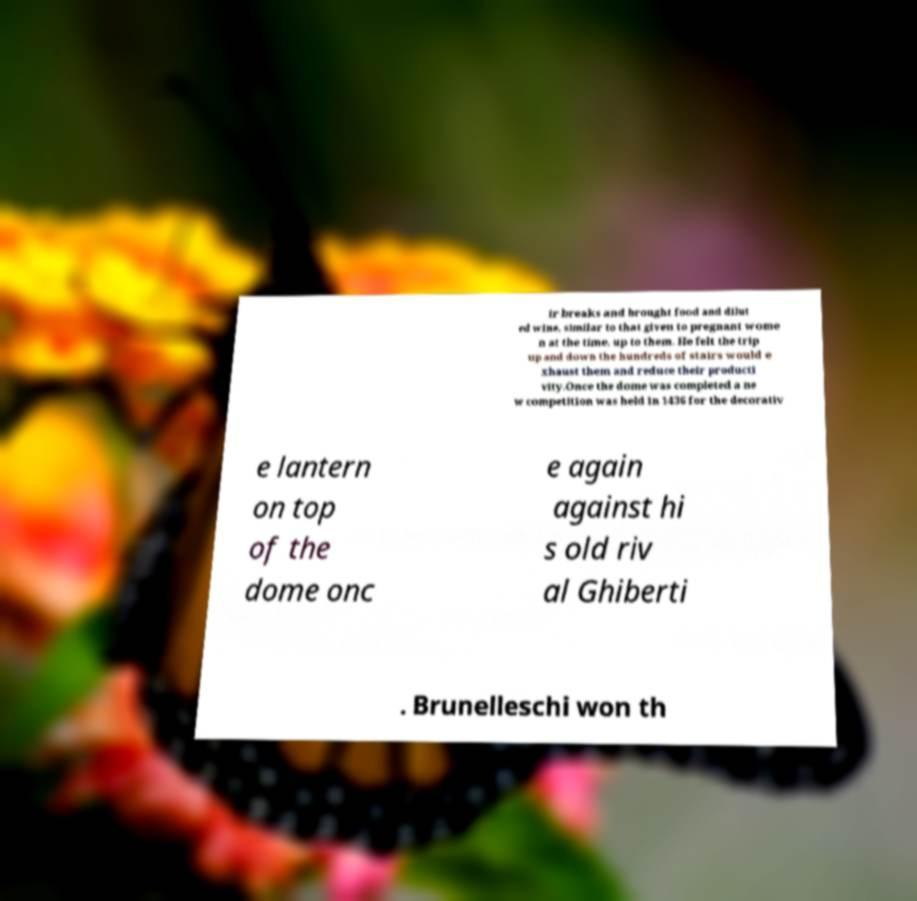What messages or text are displayed in this image? I need them in a readable, typed format. ir breaks and brought food and dilut ed wine, similar to that given to pregnant wome n at the time, up to them. He felt the trip up and down the hundreds of stairs would e xhaust them and reduce their producti vity.Once the dome was completed a ne w competition was held in 1436 for the decorativ e lantern on top of the dome onc e again against hi s old riv al Ghiberti . Brunelleschi won th 